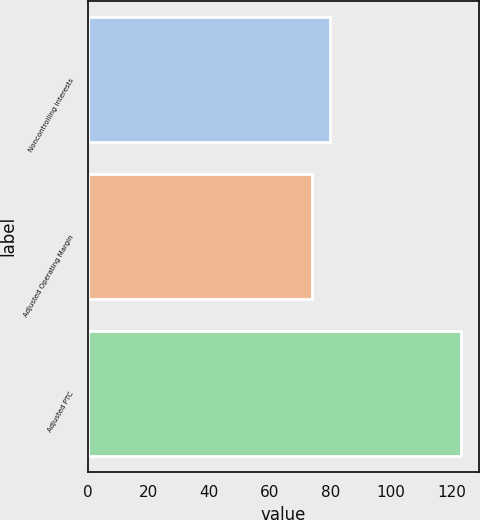Convert chart. <chart><loc_0><loc_0><loc_500><loc_500><bar_chart><fcel>Noncontrolling Interests<fcel>Adjusted Operating Margin<fcel>Adjusted PTC<nl><fcel>80<fcel>74<fcel>123<nl></chart> 